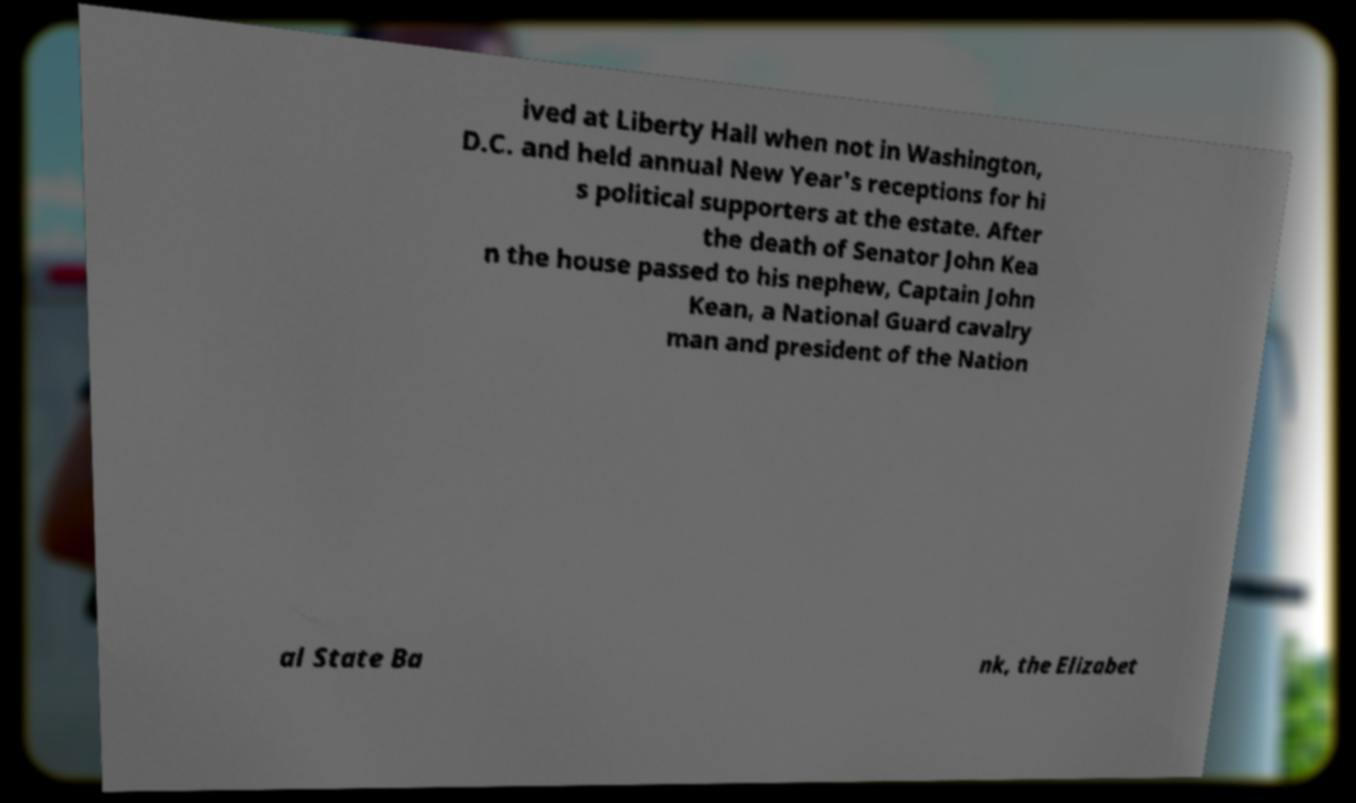Please read and relay the text visible in this image. What does it say? ived at Liberty Hall when not in Washington, D.C. and held annual New Year's receptions for hi s political supporters at the estate. After the death of Senator John Kea n the house passed to his nephew, Captain John Kean, a National Guard cavalry man and president of the Nation al State Ba nk, the Elizabet 